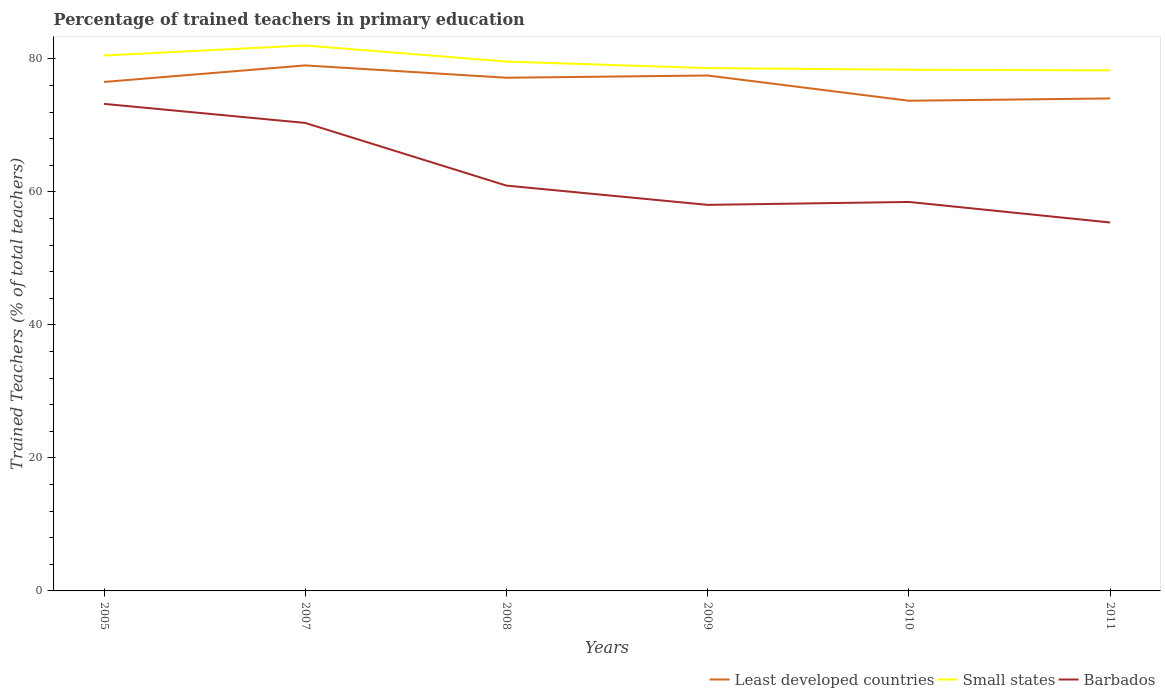How many different coloured lines are there?
Your answer should be very brief. 3. Across all years, what is the maximum percentage of trained teachers in Barbados?
Keep it short and to the point. 55.41. In which year was the percentage of trained teachers in Small states maximum?
Keep it short and to the point. 2011. What is the total percentage of trained teachers in Small states in the graph?
Provide a short and direct response. 2.43. What is the difference between the highest and the second highest percentage of trained teachers in Small states?
Provide a succinct answer. 3.75. Is the percentage of trained teachers in Barbados strictly greater than the percentage of trained teachers in Least developed countries over the years?
Your answer should be very brief. Yes. What is the difference between two consecutive major ticks on the Y-axis?
Offer a very short reply. 20. Does the graph contain any zero values?
Keep it short and to the point. No. Where does the legend appear in the graph?
Provide a succinct answer. Bottom right. How many legend labels are there?
Offer a terse response. 3. How are the legend labels stacked?
Make the answer very short. Horizontal. What is the title of the graph?
Provide a short and direct response. Percentage of trained teachers in primary education. What is the label or title of the X-axis?
Give a very brief answer. Years. What is the label or title of the Y-axis?
Your answer should be very brief. Trained Teachers (% of total teachers). What is the Trained Teachers (% of total teachers) of Least developed countries in 2005?
Ensure brevity in your answer.  76.54. What is the Trained Teachers (% of total teachers) in Small states in 2005?
Offer a terse response. 80.51. What is the Trained Teachers (% of total teachers) in Barbados in 2005?
Make the answer very short. 73.25. What is the Trained Teachers (% of total teachers) in Least developed countries in 2007?
Provide a short and direct response. 79.03. What is the Trained Teachers (% of total teachers) in Small states in 2007?
Your answer should be compact. 82.04. What is the Trained Teachers (% of total teachers) of Barbados in 2007?
Your answer should be very brief. 70.38. What is the Trained Teachers (% of total teachers) in Least developed countries in 2008?
Your answer should be very brief. 77.18. What is the Trained Teachers (% of total teachers) of Small states in 2008?
Keep it short and to the point. 79.61. What is the Trained Teachers (% of total teachers) in Barbados in 2008?
Keep it short and to the point. 60.95. What is the Trained Teachers (% of total teachers) in Least developed countries in 2009?
Offer a terse response. 77.51. What is the Trained Teachers (% of total teachers) of Small states in 2009?
Ensure brevity in your answer.  78.63. What is the Trained Teachers (% of total teachers) in Barbados in 2009?
Offer a very short reply. 58.06. What is the Trained Teachers (% of total teachers) of Least developed countries in 2010?
Provide a succinct answer. 73.72. What is the Trained Teachers (% of total teachers) of Small states in 2010?
Give a very brief answer. 78.39. What is the Trained Teachers (% of total teachers) of Barbados in 2010?
Give a very brief answer. 58.5. What is the Trained Teachers (% of total teachers) of Least developed countries in 2011?
Keep it short and to the point. 74.06. What is the Trained Teachers (% of total teachers) of Small states in 2011?
Offer a very short reply. 78.28. What is the Trained Teachers (% of total teachers) of Barbados in 2011?
Your response must be concise. 55.41. Across all years, what is the maximum Trained Teachers (% of total teachers) of Least developed countries?
Your answer should be compact. 79.03. Across all years, what is the maximum Trained Teachers (% of total teachers) in Small states?
Your answer should be very brief. 82.04. Across all years, what is the maximum Trained Teachers (% of total teachers) in Barbados?
Offer a very short reply. 73.25. Across all years, what is the minimum Trained Teachers (% of total teachers) in Least developed countries?
Provide a short and direct response. 73.72. Across all years, what is the minimum Trained Teachers (% of total teachers) of Small states?
Ensure brevity in your answer.  78.28. Across all years, what is the minimum Trained Teachers (% of total teachers) in Barbados?
Ensure brevity in your answer.  55.41. What is the total Trained Teachers (% of total teachers) in Least developed countries in the graph?
Provide a short and direct response. 458.05. What is the total Trained Teachers (% of total teachers) of Small states in the graph?
Offer a terse response. 477.46. What is the total Trained Teachers (% of total teachers) in Barbados in the graph?
Give a very brief answer. 376.54. What is the difference between the Trained Teachers (% of total teachers) of Least developed countries in 2005 and that in 2007?
Provide a short and direct response. -2.49. What is the difference between the Trained Teachers (% of total teachers) in Small states in 2005 and that in 2007?
Your answer should be very brief. -1.52. What is the difference between the Trained Teachers (% of total teachers) in Barbados in 2005 and that in 2007?
Your answer should be very brief. 2.87. What is the difference between the Trained Teachers (% of total teachers) in Least developed countries in 2005 and that in 2008?
Your answer should be compact. -0.63. What is the difference between the Trained Teachers (% of total teachers) of Small states in 2005 and that in 2008?
Keep it short and to the point. 0.91. What is the difference between the Trained Teachers (% of total teachers) in Barbados in 2005 and that in 2008?
Keep it short and to the point. 12.29. What is the difference between the Trained Teachers (% of total teachers) in Least developed countries in 2005 and that in 2009?
Your response must be concise. -0.97. What is the difference between the Trained Teachers (% of total teachers) in Small states in 2005 and that in 2009?
Offer a terse response. 1.89. What is the difference between the Trained Teachers (% of total teachers) of Barbados in 2005 and that in 2009?
Offer a very short reply. 15.19. What is the difference between the Trained Teachers (% of total teachers) in Least developed countries in 2005 and that in 2010?
Give a very brief answer. 2.83. What is the difference between the Trained Teachers (% of total teachers) of Small states in 2005 and that in 2010?
Ensure brevity in your answer.  2.13. What is the difference between the Trained Teachers (% of total teachers) in Barbados in 2005 and that in 2010?
Give a very brief answer. 14.75. What is the difference between the Trained Teachers (% of total teachers) of Least developed countries in 2005 and that in 2011?
Give a very brief answer. 2.48. What is the difference between the Trained Teachers (% of total teachers) of Small states in 2005 and that in 2011?
Ensure brevity in your answer.  2.23. What is the difference between the Trained Teachers (% of total teachers) in Barbados in 2005 and that in 2011?
Ensure brevity in your answer.  17.84. What is the difference between the Trained Teachers (% of total teachers) of Least developed countries in 2007 and that in 2008?
Keep it short and to the point. 1.85. What is the difference between the Trained Teachers (% of total teachers) in Small states in 2007 and that in 2008?
Offer a terse response. 2.43. What is the difference between the Trained Teachers (% of total teachers) in Barbados in 2007 and that in 2008?
Make the answer very short. 9.43. What is the difference between the Trained Teachers (% of total teachers) of Least developed countries in 2007 and that in 2009?
Make the answer very short. 1.52. What is the difference between the Trained Teachers (% of total teachers) of Small states in 2007 and that in 2009?
Your response must be concise. 3.41. What is the difference between the Trained Teachers (% of total teachers) in Barbados in 2007 and that in 2009?
Your response must be concise. 12.32. What is the difference between the Trained Teachers (% of total teachers) in Least developed countries in 2007 and that in 2010?
Make the answer very short. 5.31. What is the difference between the Trained Teachers (% of total teachers) in Small states in 2007 and that in 2010?
Give a very brief answer. 3.65. What is the difference between the Trained Teachers (% of total teachers) of Barbados in 2007 and that in 2010?
Your answer should be compact. 11.88. What is the difference between the Trained Teachers (% of total teachers) of Least developed countries in 2007 and that in 2011?
Offer a very short reply. 4.97. What is the difference between the Trained Teachers (% of total teachers) in Small states in 2007 and that in 2011?
Your answer should be very brief. 3.75. What is the difference between the Trained Teachers (% of total teachers) of Barbados in 2007 and that in 2011?
Your answer should be compact. 14.97. What is the difference between the Trained Teachers (% of total teachers) in Least developed countries in 2008 and that in 2009?
Ensure brevity in your answer.  -0.34. What is the difference between the Trained Teachers (% of total teachers) of Small states in 2008 and that in 2009?
Give a very brief answer. 0.98. What is the difference between the Trained Teachers (% of total teachers) of Barbados in 2008 and that in 2009?
Offer a very short reply. 2.9. What is the difference between the Trained Teachers (% of total teachers) of Least developed countries in 2008 and that in 2010?
Provide a short and direct response. 3.46. What is the difference between the Trained Teachers (% of total teachers) of Small states in 2008 and that in 2010?
Ensure brevity in your answer.  1.22. What is the difference between the Trained Teachers (% of total teachers) in Barbados in 2008 and that in 2010?
Keep it short and to the point. 2.46. What is the difference between the Trained Teachers (% of total teachers) of Least developed countries in 2008 and that in 2011?
Make the answer very short. 3.11. What is the difference between the Trained Teachers (% of total teachers) in Small states in 2008 and that in 2011?
Your answer should be very brief. 1.33. What is the difference between the Trained Teachers (% of total teachers) in Barbados in 2008 and that in 2011?
Provide a succinct answer. 5.55. What is the difference between the Trained Teachers (% of total teachers) in Least developed countries in 2009 and that in 2010?
Your answer should be compact. 3.79. What is the difference between the Trained Teachers (% of total teachers) in Small states in 2009 and that in 2010?
Provide a short and direct response. 0.24. What is the difference between the Trained Teachers (% of total teachers) in Barbados in 2009 and that in 2010?
Give a very brief answer. -0.44. What is the difference between the Trained Teachers (% of total teachers) in Least developed countries in 2009 and that in 2011?
Make the answer very short. 3.45. What is the difference between the Trained Teachers (% of total teachers) in Small states in 2009 and that in 2011?
Provide a short and direct response. 0.34. What is the difference between the Trained Teachers (% of total teachers) of Barbados in 2009 and that in 2011?
Offer a very short reply. 2.65. What is the difference between the Trained Teachers (% of total teachers) in Least developed countries in 2010 and that in 2011?
Your answer should be compact. -0.35. What is the difference between the Trained Teachers (% of total teachers) in Small states in 2010 and that in 2011?
Offer a very short reply. 0.1. What is the difference between the Trained Teachers (% of total teachers) of Barbados in 2010 and that in 2011?
Ensure brevity in your answer.  3.09. What is the difference between the Trained Teachers (% of total teachers) of Least developed countries in 2005 and the Trained Teachers (% of total teachers) of Small states in 2007?
Offer a terse response. -5.49. What is the difference between the Trained Teachers (% of total teachers) of Least developed countries in 2005 and the Trained Teachers (% of total teachers) of Barbados in 2007?
Provide a short and direct response. 6.16. What is the difference between the Trained Teachers (% of total teachers) of Small states in 2005 and the Trained Teachers (% of total teachers) of Barbados in 2007?
Make the answer very short. 10.13. What is the difference between the Trained Teachers (% of total teachers) of Least developed countries in 2005 and the Trained Teachers (% of total teachers) of Small states in 2008?
Provide a short and direct response. -3.07. What is the difference between the Trained Teachers (% of total teachers) in Least developed countries in 2005 and the Trained Teachers (% of total teachers) in Barbados in 2008?
Ensure brevity in your answer.  15.59. What is the difference between the Trained Teachers (% of total teachers) in Small states in 2005 and the Trained Teachers (% of total teachers) in Barbados in 2008?
Ensure brevity in your answer.  19.56. What is the difference between the Trained Teachers (% of total teachers) in Least developed countries in 2005 and the Trained Teachers (% of total teachers) in Small states in 2009?
Provide a short and direct response. -2.08. What is the difference between the Trained Teachers (% of total teachers) of Least developed countries in 2005 and the Trained Teachers (% of total teachers) of Barbados in 2009?
Offer a terse response. 18.48. What is the difference between the Trained Teachers (% of total teachers) of Small states in 2005 and the Trained Teachers (% of total teachers) of Barbados in 2009?
Provide a short and direct response. 22.46. What is the difference between the Trained Teachers (% of total teachers) of Least developed countries in 2005 and the Trained Teachers (% of total teachers) of Small states in 2010?
Make the answer very short. -1.84. What is the difference between the Trained Teachers (% of total teachers) of Least developed countries in 2005 and the Trained Teachers (% of total teachers) of Barbados in 2010?
Keep it short and to the point. 18.05. What is the difference between the Trained Teachers (% of total teachers) of Small states in 2005 and the Trained Teachers (% of total teachers) of Barbados in 2010?
Provide a succinct answer. 22.02. What is the difference between the Trained Teachers (% of total teachers) of Least developed countries in 2005 and the Trained Teachers (% of total teachers) of Small states in 2011?
Offer a terse response. -1.74. What is the difference between the Trained Teachers (% of total teachers) of Least developed countries in 2005 and the Trained Teachers (% of total teachers) of Barbados in 2011?
Offer a very short reply. 21.14. What is the difference between the Trained Teachers (% of total teachers) in Small states in 2005 and the Trained Teachers (% of total teachers) in Barbados in 2011?
Give a very brief answer. 25.11. What is the difference between the Trained Teachers (% of total teachers) in Least developed countries in 2007 and the Trained Teachers (% of total teachers) in Small states in 2008?
Provide a succinct answer. -0.58. What is the difference between the Trained Teachers (% of total teachers) of Least developed countries in 2007 and the Trained Teachers (% of total teachers) of Barbados in 2008?
Your response must be concise. 18.08. What is the difference between the Trained Teachers (% of total teachers) in Small states in 2007 and the Trained Teachers (% of total teachers) in Barbados in 2008?
Your answer should be compact. 21.08. What is the difference between the Trained Teachers (% of total teachers) of Least developed countries in 2007 and the Trained Teachers (% of total teachers) of Small states in 2009?
Your response must be concise. 0.41. What is the difference between the Trained Teachers (% of total teachers) of Least developed countries in 2007 and the Trained Teachers (% of total teachers) of Barbados in 2009?
Ensure brevity in your answer.  20.97. What is the difference between the Trained Teachers (% of total teachers) in Small states in 2007 and the Trained Teachers (% of total teachers) in Barbados in 2009?
Your answer should be very brief. 23.98. What is the difference between the Trained Teachers (% of total teachers) of Least developed countries in 2007 and the Trained Teachers (% of total teachers) of Small states in 2010?
Make the answer very short. 0.65. What is the difference between the Trained Teachers (% of total teachers) in Least developed countries in 2007 and the Trained Teachers (% of total teachers) in Barbados in 2010?
Keep it short and to the point. 20.54. What is the difference between the Trained Teachers (% of total teachers) of Small states in 2007 and the Trained Teachers (% of total teachers) of Barbados in 2010?
Keep it short and to the point. 23.54. What is the difference between the Trained Teachers (% of total teachers) of Least developed countries in 2007 and the Trained Teachers (% of total teachers) of Small states in 2011?
Ensure brevity in your answer.  0.75. What is the difference between the Trained Teachers (% of total teachers) in Least developed countries in 2007 and the Trained Teachers (% of total teachers) in Barbados in 2011?
Give a very brief answer. 23.62. What is the difference between the Trained Teachers (% of total teachers) in Small states in 2007 and the Trained Teachers (% of total teachers) in Barbados in 2011?
Offer a very short reply. 26.63. What is the difference between the Trained Teachers (% of total teachers) of Least developed countries in 2008 and the Trained Teachers (% of total teachers) of Small states in 2009?
Make the answer very short. -1.45. What is the difference between the Trained Teachers (% of total teachers) in Least developed countries in 2008 and the Trained Teachers (% of total teachers) in Barbados in 2009?
Your answer should be very brief. 19.12. What is the difference between the Trained Teachers (% of total teachers) in Small states in 2008 and the Trained Teachers (% of total teachers) in Barbados in 2009?
Make the answer very short. 21.55. What is the difference between the Trained Teachers (% of total teachers) of Least developed countries in 2008 and the Trained Teachers (% of total teachers) of Small states in 2010?
Make the answer very short. -1.21. What is the difference between the Trained Teachers (% of total teachers) in Least developed countries in 2008 and the Trained Teachers (% of total teachers) in Barbados in 2010?
Keep it short and to the point. 18.68. What is the difference between the Trained Teachers (% of total teachers) of Small states in 2008 and the Trained Teachers (% of total teachers) of Barbados in 2010?
Keep it short and to the point. 21.11. What is the difference between the Trained Teachers (% of total teachers) of Least developed countries in 2008 and the Trained Teachers (% of total teachers) of Small states in 2011?
Provide a succinct answer. -1.11. What is the difference between the Trained Teachers (% of total teachers) of Least developed countries in 2008 and the Trained Teachers (% of total teachers) of Barbados in 2011?
Make the answer very short. 21.77. What is the difference between the Trained Teachers (% of total teachers) of Small states in 2008 and the Trained Teachers (% of total teachers) of Barbados in 2011?
Give a very brief answer. 24.2. What is the difference between the Trained Teachers (% of total teachers) of Least developed countries in 2009 and the Trained Teachers (% of total teachers) of Small states in 2010?
Keep it short and to the point. -0.87. What is the difference between the Trained Teachers (% of total teachers) of Least developed countries in 2009 and the Trained Teachers (% of total teachers) of Barbados in 2010?
Give a very brief answer. 19.02. What is the difference between the Trained Teachers (% of total teachers) in Small states in 2009 and the Trained Teachers (% of total teachers) in Barbados in 2010?
Give a very brief answer. 20.13. What is the difference between the Trained Teachers (% of total teachers) of Least developed countries in 2009 and the Trained Teachers (% of total teachers) of Small states in 2011?
Offer a very short reply. -0.77. What is the difference between the Trained Teachers (% of total teachers) in Least developed countries in 2009 and the Trained Teachers (% of total teachers) in Barbados in 2011?
Make the answer very short. 22.11. What is the difference between the Trained Teachers (% of total teachers) in Small states in 2009 and the Trained Teachers (% of total teachers) in Barbados in 2011?
Ensure brevity in your answer.  23.22. What is the difference between the Trained Teachers (% of total teachers) in Least developed countries in 2010 and the Trained Teachers (% of total teachers) in Small states in 2011?
Ensure brevity in your answer.  -4.57. What is the difference between the Trained Teachers (% of total teachers) of Least developed countries in 2010 and the Trained Teachers (% of total teachers) of Barbados in 2011?
Provide a succinct answer. 18.31. What is the difference between the Trained Teachers (% of total teachers) in Small states in 2010 and the Trained Teachers (% of total teachers) in Barbados in 2011?
Give a very brief answer. 22.98. What is the average Trained Teachers (% of total teachers) in Least developed countries per year?
Keep it short and to the point. 76.34. What is the average Trained Teachers (% of total teachers) of Small states per year?
Provide a short and direct response. 79.58. What is the average Trained Teachers (% of total teachers) of Barbados per year?
Give a very brief answer. 62.76. In the year 2005, what is the difference between the Trained Teachers (% of total teachers) in Least developed countries and Trained Teachers (% of total teachers) in Small states?
Provide a short and direct response. -3.97. In the year 2005, what is the difference between the Trained Teachers (% of total teachers) of Least developed countries and Trained Teachers (% of total teachers) of Barbados?
Provide a short and direct response. 3.3. In the year 2005, what is the difference between the Trained Teachers (% of total teachers) in Small states and Trained Teachers (% of total teachers) in Barbados?
Offer a terse response. 7.27. In the year 2007, what is the difference between the Trained Teachers (% of total teachers) in Least developed countries and Trained Teachers (% of total teachers) in Small states?
Give a very brief answer. -3. In the year 2007, what is the difference between the Trained Teachers (% of total teachers) in Least developed countries and Trained Teachers (% of total teachers) in Barbados?
Provide a succinct answer. 8.65. In the year 2007, what is the difference between the Trained Teachers (% of total teachers) in Small states and Trained Teachers (% of total teachers) in Barbados?
Provide a short and direct response. 11.66. In the year 2008, what is the difference between the Trained Teachers (% of total teachers) of Least developed countries and Trained Teachers (% of total teachers) of Small states?
Ensure brevity in your answer.  -2.43. In the year 2008, what is the difference between the Trained Teachers (% of total teachers) in Least developed countries and Trained Teachers (% of total teachers) in Barbados?
Your answer should be very brief. 16.22. In the year 2008, what is the difference between the Trained Teachers (% of total teachers) in Small states and Trained Teachers (% of total teachers) in Barbados?
Your answer should be very brief. 18.66. In the year 2009, what is the difference between the Trained Teachers (% of total teachers) of Least developed countries and Trained Teachers (% of total teachers) of Small states?
Your answer should be very brief. -1.11. In the year 2009, what is the difference between the Trained Teachers (% of total teachers) of Least developed countries and Trained Teachers (% of total teachers) of Barbados?
Your answer should be very brief. 19.45. In the year 2009, what is the difference between the Trained Teachers (% of total teachers) in Small states and Trained Teachers (% of total teachers) in Barbados?
Ensure brevity in your answer.  20.57. In the year 2010, what is the difference between the Trained Teachers (% of total teachers) in Least developed countries and Trained Teachers (% of total teachers) in Small states?
Give a very brief answer. -4.67. In the year 2010, what is the difference between the Trained Teachers (% of total teachers) of Least developed countries and Trained Teachers (% of total teachers) of Barbados?
Your answer should be compact. 15.22. In the year 2010, what is the difference between the Trained Teachers (% of total teachers) of Small states and Trained Teachers (% of total teachers) of Barbados?
Your answer should be compact. 19.89. In the year 2011, what is the difference between the Trained Teachers (% of total teachers) in Least developed countries and Trained Teachers (% of total teachers) in Small states?
Your answer should be very brief. -4.22. In the year 2011, what is the difference between the Trained Teachers (% of total teachers) of Least developed countries and Trained Teachers (% of total teachers) of Barbados?
Make the answer very short. 18.66. In the year 2011, what is the difference between the Trained Teachers (% of total teachers) of Small states and Trained Teachers (% of total teachers) of Barbados?
Make the answer very short. 22.88. What is the ratio of the Trained Teachers (% of total teachers) of Least developed countries in 2005 to that in 2007?
Your answer should be very brief. 0.97. What is the ratio of the Trained Teachers (% of total teachers) in Small states in 2005 to that in 2007?
Offer a very short reply. 0.98. What is the ratio of the Trained Teachers (% of total teachers) in Barbados in 2005 to that in 2007?
Your answer should be compact. 1.04. What is the ratio of the Trained Teachers (% of total teachers) in Small states in 2005 to that in 2008?
Give a very brief answer. 1.01. What is the ratio of the Trained Teachers (% of total teachers) in Barbados in 2005 to that in 2008?
Your answer should be compact. 1.2. What is the ratio of the Trained Teachers (% of total teachers) of Least developed countries in 2005 to that in 2009?
Give a very brief answer. 0.99. What is the ratio of the Trained Teachers (% of total teachers) of Barbados in 2005 to that in 2009?
Give a very brief answer. 1.26. What is the ratio of the Trained Teachers (% of total teachers) of Least developed countries in 2005 to that in 2010?
Ensure brevity in your answer.  1.04. What is the ratio of the Trained Teachers (% of total teachers) of Small states in 2005 to that in 2010?
Offer a terse response. 1.03. What is the ratio of the Trained Teachers (% of total teachers) in Barbados in 2005 to that in 2010?
Ensure brevity in your answer.  1.25. What is the ratio of the Trained Teachers (% of total teachers) of Least developed countries in 2005 to that in 2011?
Your answer should be very brief. 1.03. What is the ratio of the Trained Teachers (% of total teachers) of Small states in 2005 to that in 2011?
Your answer should be compact. 1.03. What is the ratio of the Trained Teachers (% of total teachers) of Barbados in 2005 to that in 2011?
Ensure brevity in your answer.  1.32. What is the ratio of the Trained Teachers (% of total teachers) in Least developed countries in 2007 to that in 2008?
Offer a very short reply. 1.02. What is the ratio of the Trained Teachers (% of total teachers) in Small states in 2007 to that in 2008?
Keep it short and to the point. 1.03. What is the ratio of the Trained Teachers (% of total teachers) of Barbados in 2007 to that in 2008?
Make the answer very short. 1.15. What is the ratio of the Trained Teachers (% of total teachers) in Least developed countries in 2007 to that in 2009?
Make the answer very short. 1.02. What is the ratio of the Trained Teachers (% of total teachers) of Small states in 2007 to that in 2009?
Offer a very short reply. 1.04. What is the ratio of the Trained Teachers (% of total teachers) of Barbados in 2007 to that in 2009?
Give a very brief answer. 1.21. What is the ratio of the Trained Teachers (% of total teachers) in Least developed countries in 2007 to that in 2010?
Provide a succinct answer. 1.07. What is the ratio of the Trained Teachers (% of total teachers) in Small states in 2007 to that in 2010?
Your answer should be compact. 1.05. What is the ratio of the Trained Teachers (% of total teachers) of Barbados in 2007 to that in 2010?
Make the answer very short. 1.2. What is the ratio of the Trained Teachers (% of total teachers) of Least developed countries in 2007 to that in 2011?
Keep it short and to the point. 1.07. What is the ratio of the Trained Teachers (% of total teachers) of Small states in 2007 to that in 2011?
Offer a terse response. 1.05. What is the ratio of the Trained Teachers (% of total teachers) of Barbados in 2007 to that in 2011?
Give a very brief answer. 1.27. What is the ratio of the Trained Teachers (% of total teachers) of Least developed countries in 2008 to that in 2009?
Offer a very short reply. 1. What is the ratio of the Trained Teachers (% of total teachers) in Small states in 2008 to that in 2009?
Your answer should be compact. 1.01. What is the ratio of the Trained Teachers (% of total teachers) in Barbados in 2008 to that in 2009?
Provide a succinct answer. 1.05. What is the ratio of the Trained Teachers (% of total teachers) of Least developed countries in 2008 to that in 2010?
Ensure brevity in your answer.  1.05. What is the ratio of the Trained Teachers (% of total teachers) in Small states in 2008 to that in 2010?
Your answer should be compact. 1.02. What is the ratio of the Trained Teachers (% of total teachers) in Barbados in 2008 to that in 2010?
Provide a succinct answer. 1.04. What is the ratio of the Trained Teachers (% of total teachers) of Least developed countries in 2008 to that in 2011?
Make the answer very short. 1.04. What is the ratio of the Trained Teachers (% of total teachers) of Small states in 2008 to that in 2011?
Offer a terse response. 1.02. What is the ratio of the Trained Teachers (% of total teachers) of Barbados in 2008 to that in 2011?
Provide a short and direct response. 1.1. What is the ratio of the Trained Teachers (% of total teachers) in Least developed countries in 2009 to that in 2010?
Ensure brevity in your answer.  1.05. What is the ratio of the Trained Teachers (% of total teachers) in Least developed countries in 2009 to that in 2011?
Make the answer very short. 1.05. What is the ratio of the Trained Teachers (% of total teachers) in Barbados in 2009 to that in 2011?
Keep it short and to the point. 1.05. What is the ratio of the Trained Teachers (% of total teachers) of Small states in 2010 to that in 2011?
Your response must be concise. 1. What is the ratio of the Trained Teachers (% of total teachers) of Barbados in 2010 to that in 2011?
Provide a succinct answer. 1.06. What is the difference between the highest and the second highest Trained Teachers (% of total teachers) in Least developed countries?
Your response must be concise. 1.52. What is the difference between the highest and the second highest Trained Teachers (% of total teachers) in Small states?
Your response must be concise. 1.52. What is the difference between the highest and the second highest Trained Teachers (% of total teachers) in Barbados?
Provide a short and direct response. 2.87. What is the difference between the highest and the lowest Trained Teachers (% of total teachers) in Least developed countries?
Keep it short and to the point. 5.31. What is the difference between the highest and the lowest Trained Teachers (% of total teachers) of Small states?
Make the answer very short. 3.75. What is the difference between the highest and the lowest Trained Teachers (% of total teachers) of Barbados?
Your response must be concise. 17.84. 